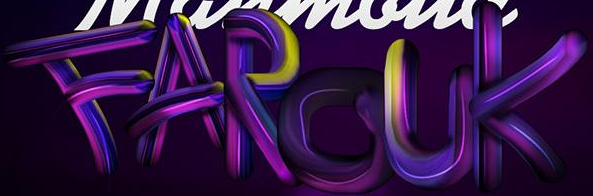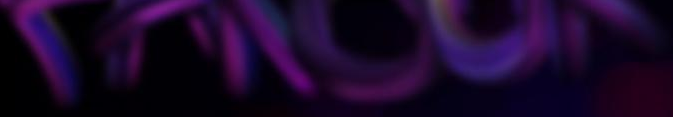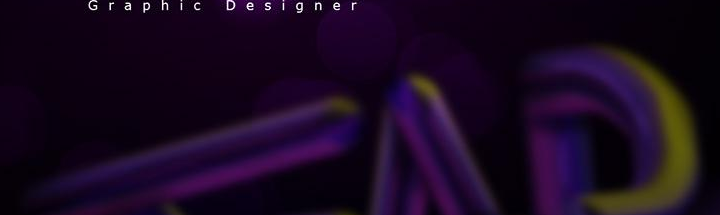Read the text content from these images in order, separated by a semicolon. FAROUK; ######; ### 